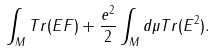Convert formula to latex. <formula><loc_0><loc_0><loc_500><loc_500>\int _ { M } T r ( E F ) + \frac { e ^ { 2 } } { 2 } \int _ { M } d \mu T r ( E ^ { 2 } ) .</formula> 